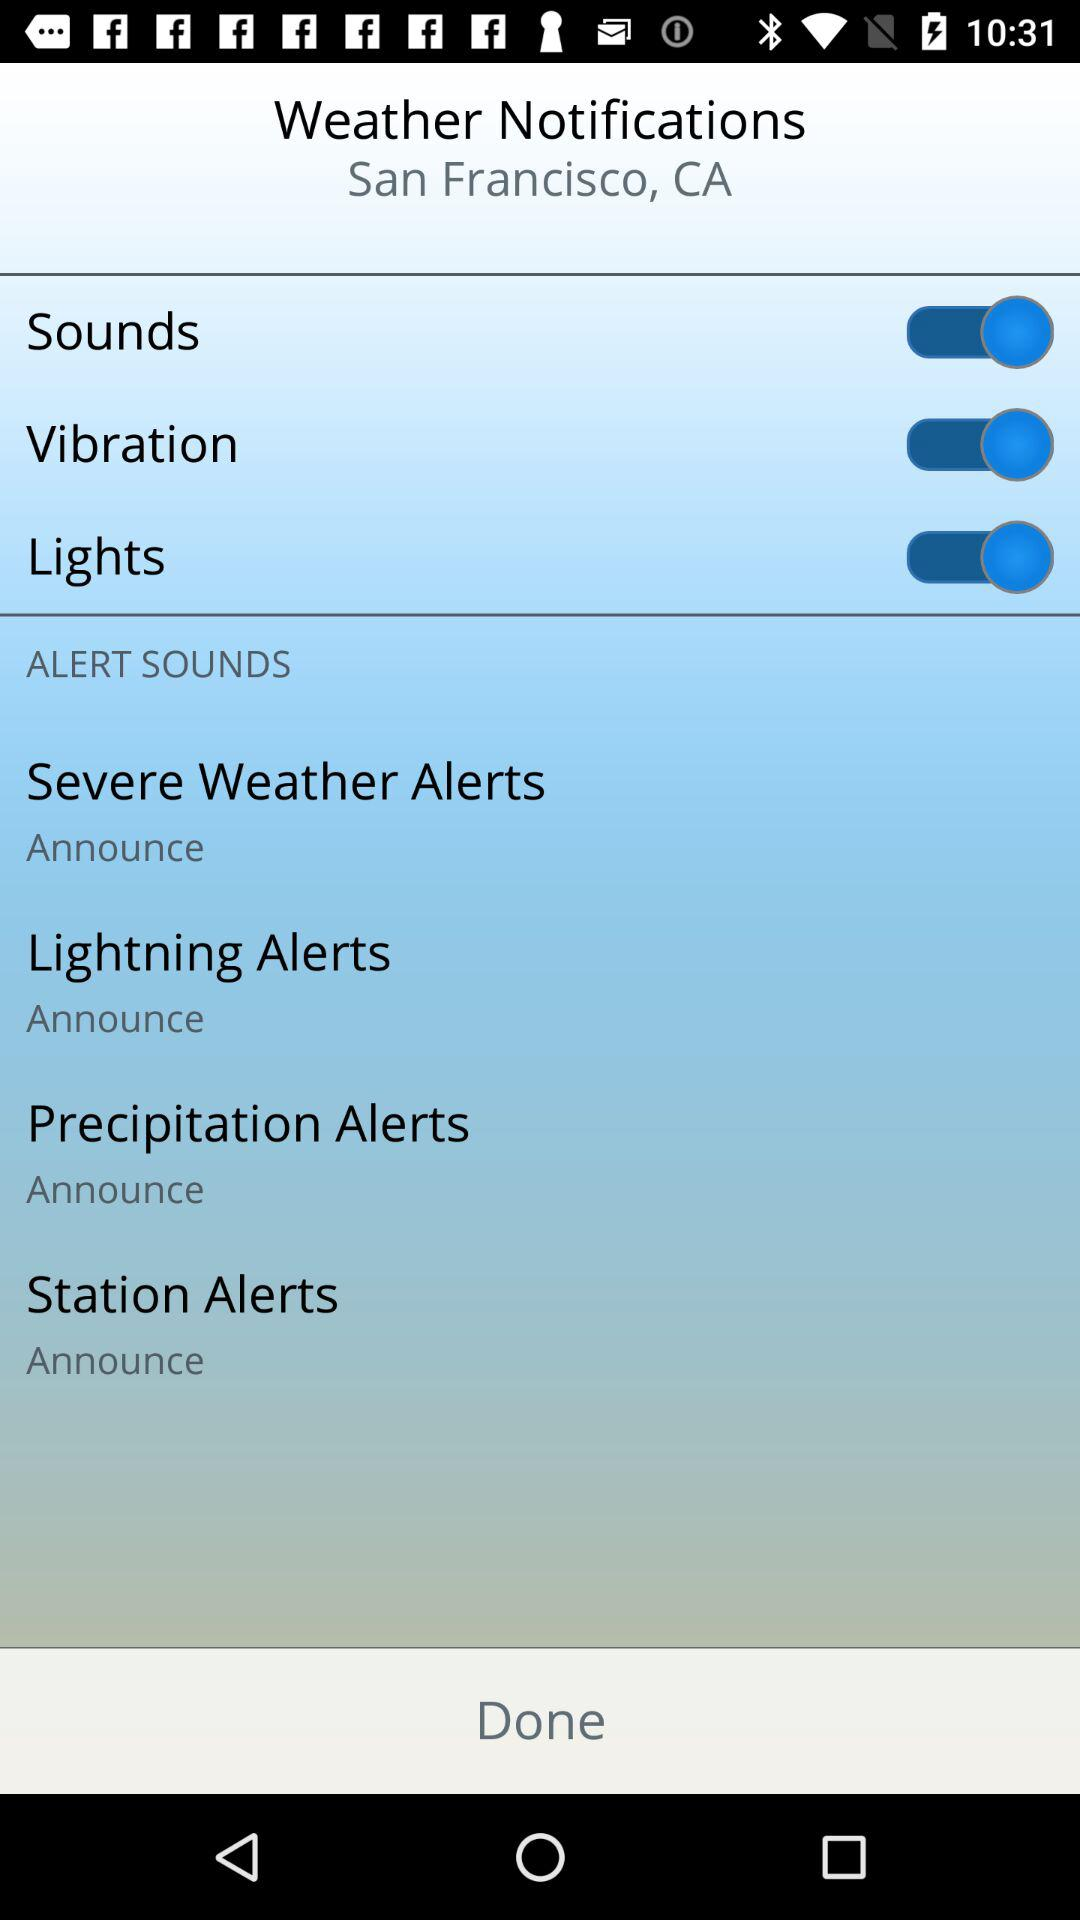What is the status of the "Sounds"? The status is "on". 